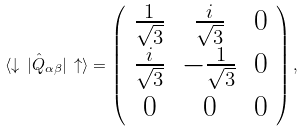Convert formula to latex. <formula><loc_0><loc_0><loc_500><loc_500>\langle \downarrow \, | \hat { Q } _ { \alpha \beta } | \, \uparrow \rangle = \left ( \begin{array} { c c c } \frac { 1 } { \sqrt { 3 } } & \frac { i } { \sqrt { 3 } } & 0 \\ \frac { i } { \sqrt { 3 } } & - \frac { 1 } { \sqrt { 3 } } & 0 \\ 0 & 0 & 0 \end{array} \right ) ,</formula> 